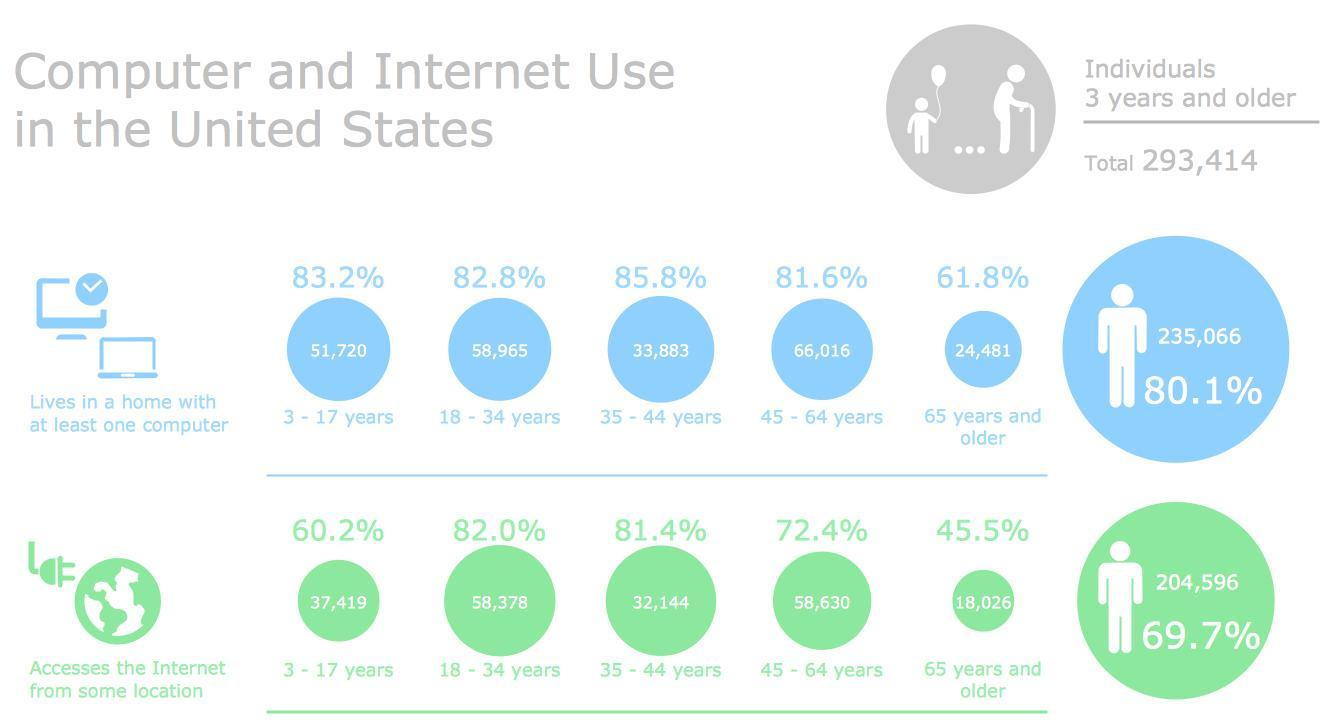how many below 35 years have a access to internet
Answer the question with a short phrase. 95797 how many below 35 years have a computer at home 110685 how many below 35 have a computer at home but cannot access the internet 14888 what percentage of senior citizens have access to internet from some location 45.5% how many senior citizens have a computer at home 24,481 